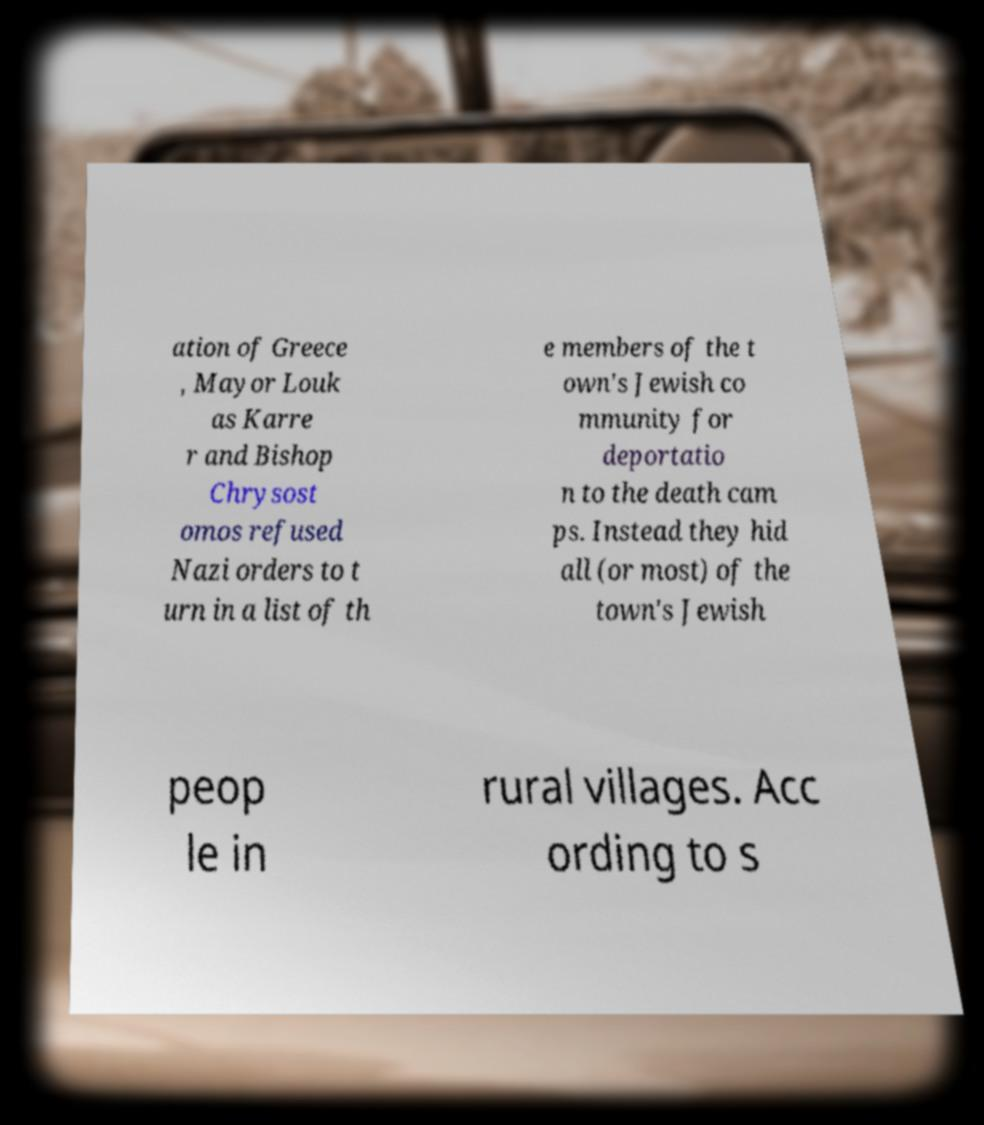Please identify and transcribe the text found in this image. ation of Greece , Mayor Louk as Karre r and Bishop Chrysost omos refused Nazi orders to t urn in a list of th e members of the t own's Jewish co mmunity for deportatio n to the death cam ps. Instead they hid all (or most) of the town's Jewish peop le in rural villages. Acc ording to s 